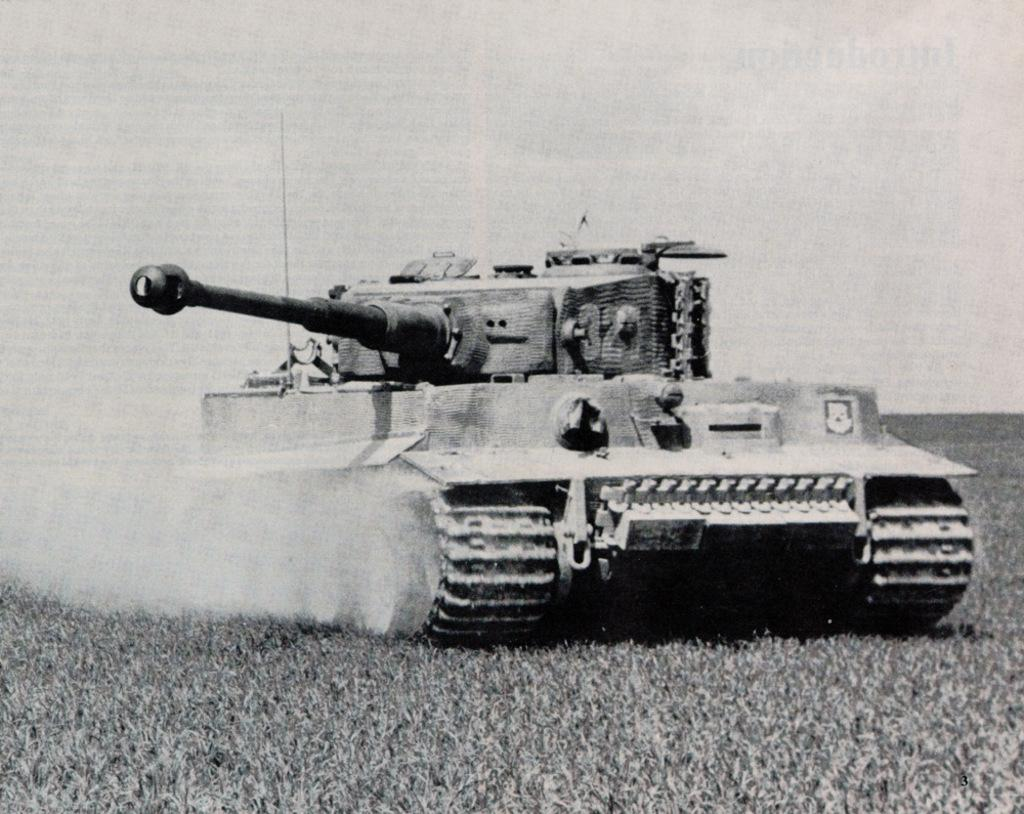What is the color scheme of the image? The image is black and white. What is the main subject of the image? There is a battle tank in the image. Where is the battle tank located? The battle tank is on the grass. What type of music can be heard playing in the background of the image? There is no music present in the image, as it is a still photograph of a battle tank on the grass. 